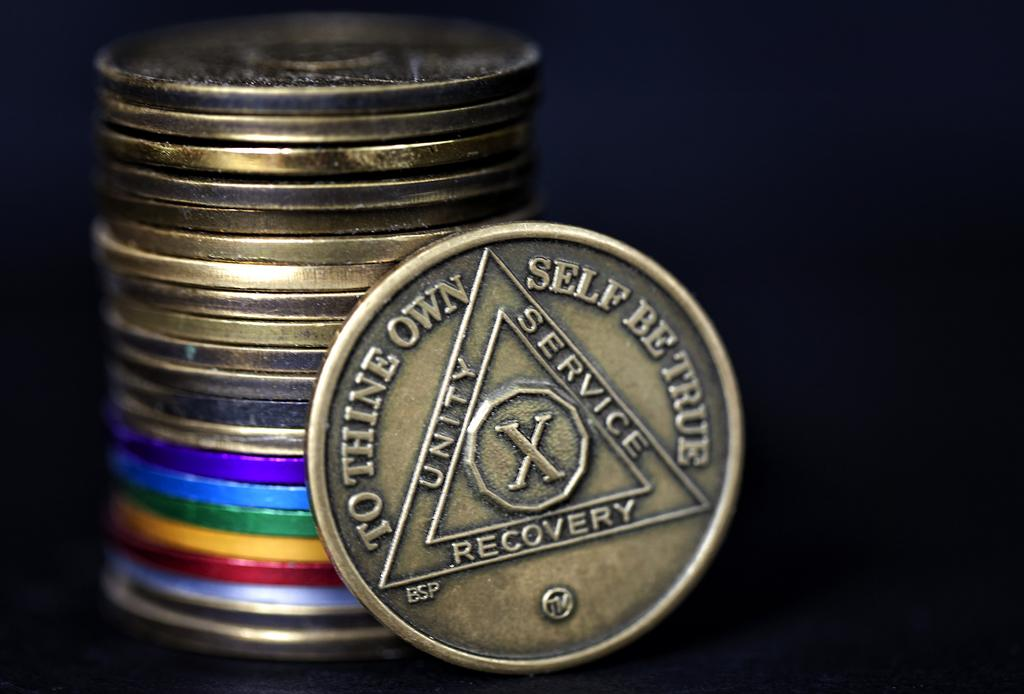<image>
Describe the image concisely. the word recovery is on the back of the coin 